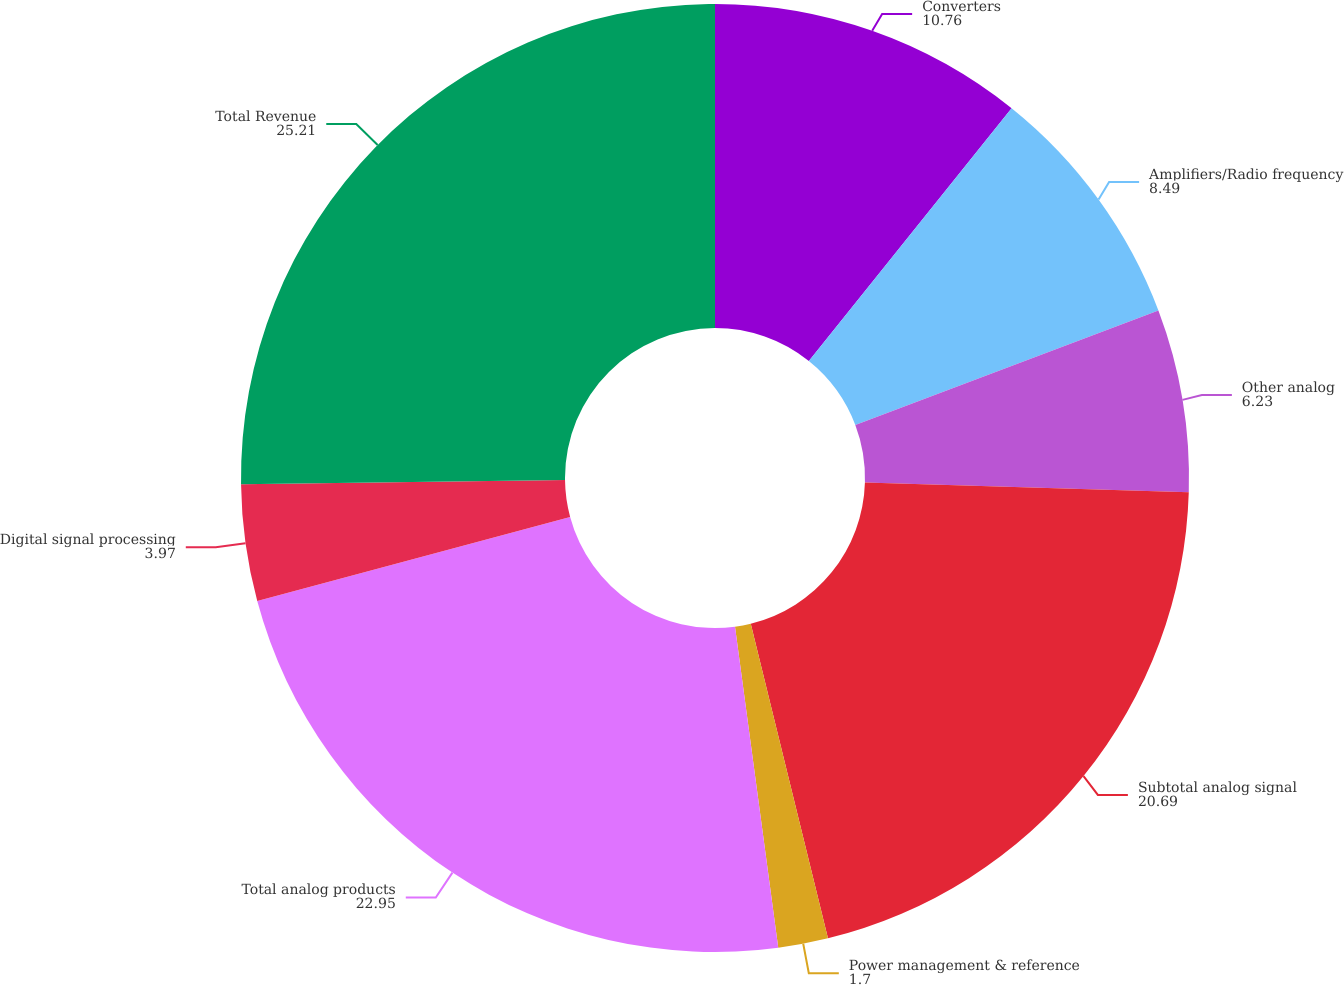Convert chart to OTSL. <chart><loc_0><loc_0><loc_500><loc_500><pie_chart><fcel>Converters<fcel>Amplifiers/Radio frequency<fcel>Other analog<fcel>Subtotal analog signal<fcel>Power management & reference<fcel>Total analog products<fcel>Digital signal processing<fcel>Total Revenue<nl><fcel>10.76%<fcel>8.49%<fcel>6.23%<fcel>20.69%<fcel>1.7%<fcel>22.95%<fcel>3.97%<fcel>25.21%<nl></chart> 